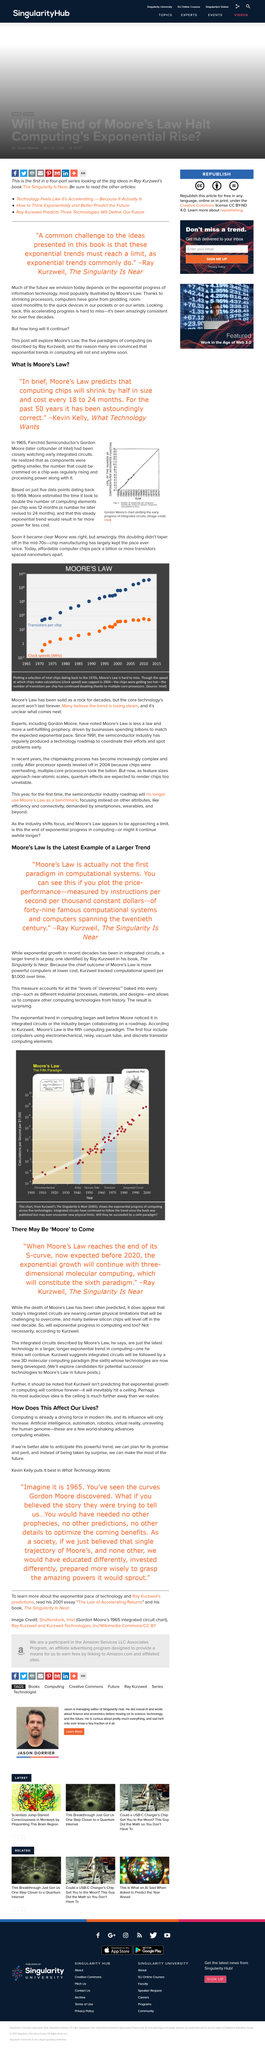Give some essential details in this illustration. Ray Kurzweil was quoted in "The Singularity is Near. According to Ray Kurzweil, exponential progress in computing will not necessarily come to an end, even though the death of Moore's Law seems imminent. It is predicted that Moore's Law will reach the end of its S-curve before the year 2020. 